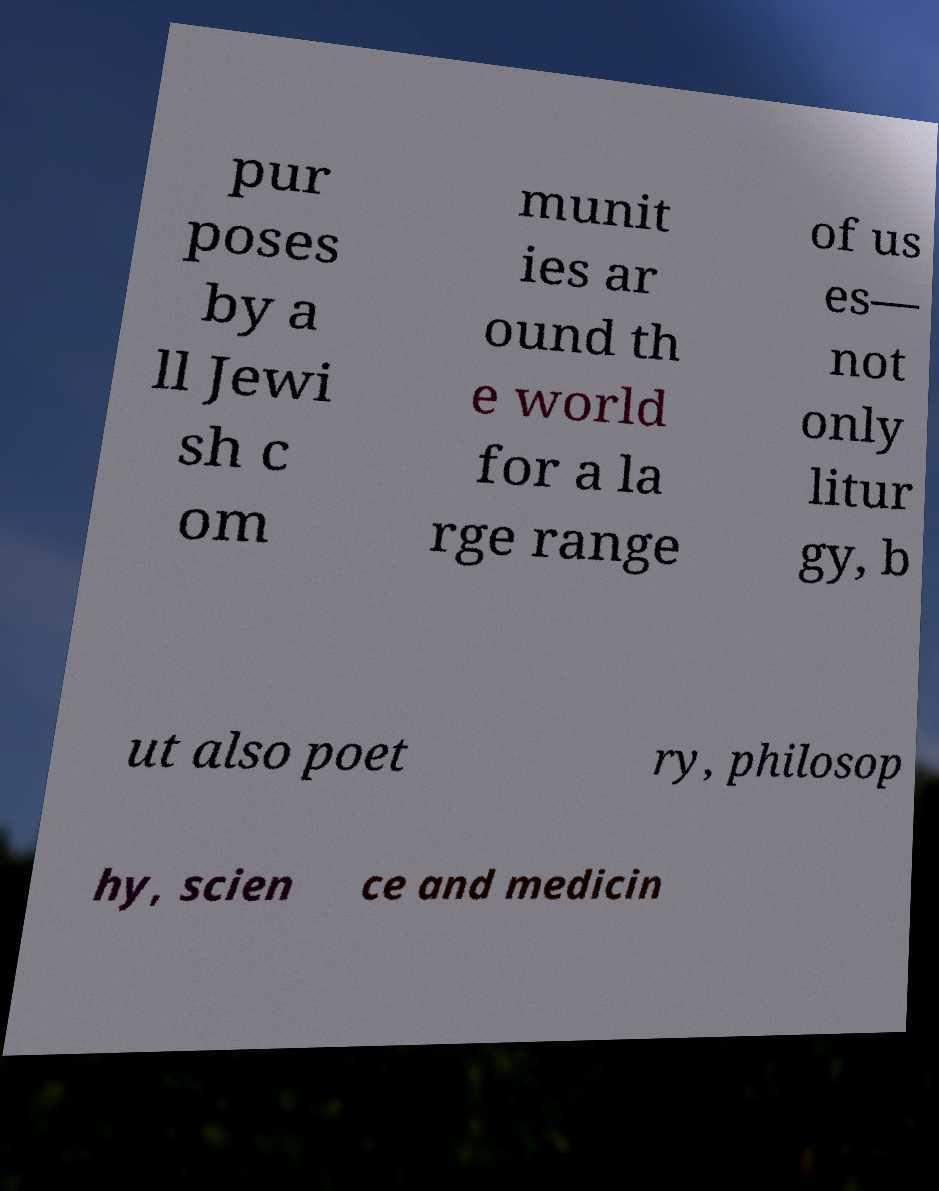There's text embedded in this image that I need extracted. Can you transcribe it verbatim? pur poses by a ll Jewi sh c om munit ies ar ound th e world for a la rge range of us es— not only litur gy, b ut also poet ry, philosop hy, scien ce and medicin 